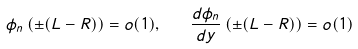Convert formula to latex. <formula><loc_0><loc_0><loc_500><loc_500>\phi _ { n } \left ( \pm ( L - R ) \right ) = o ( 1 ) , \quad \frac { d \phi _ { n } } { d y } \left ( \pm ( L - R ) \right ) = o ( 1 )</formula> 